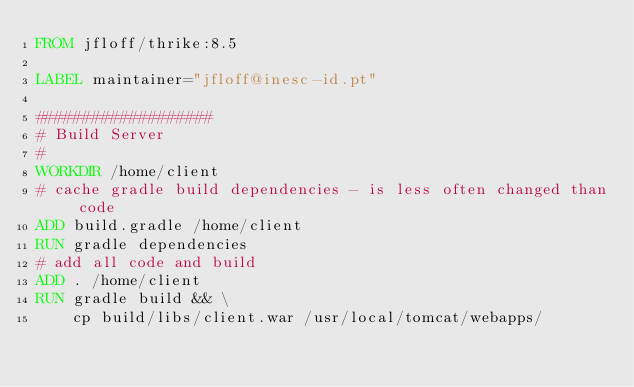Convert code to text. <code><loc_0><loc_0><loc_500><loc_500><_Dockerfile_>FROM jfloff/thrike:8.5

LABEL maintainer="jfloff@inesc-id.pt"

###################
# Build Server
#
WORKDIR /home/client
# cache gradle build dependencies - is less often changed than code
ADD build.gradle /home/client
RUN gradle dependencies
# add all code and build
ADD . /home/client
RUN gradle build && \
    cp build/libs/client.war /usr/local/tomcat/webapps/</code> 